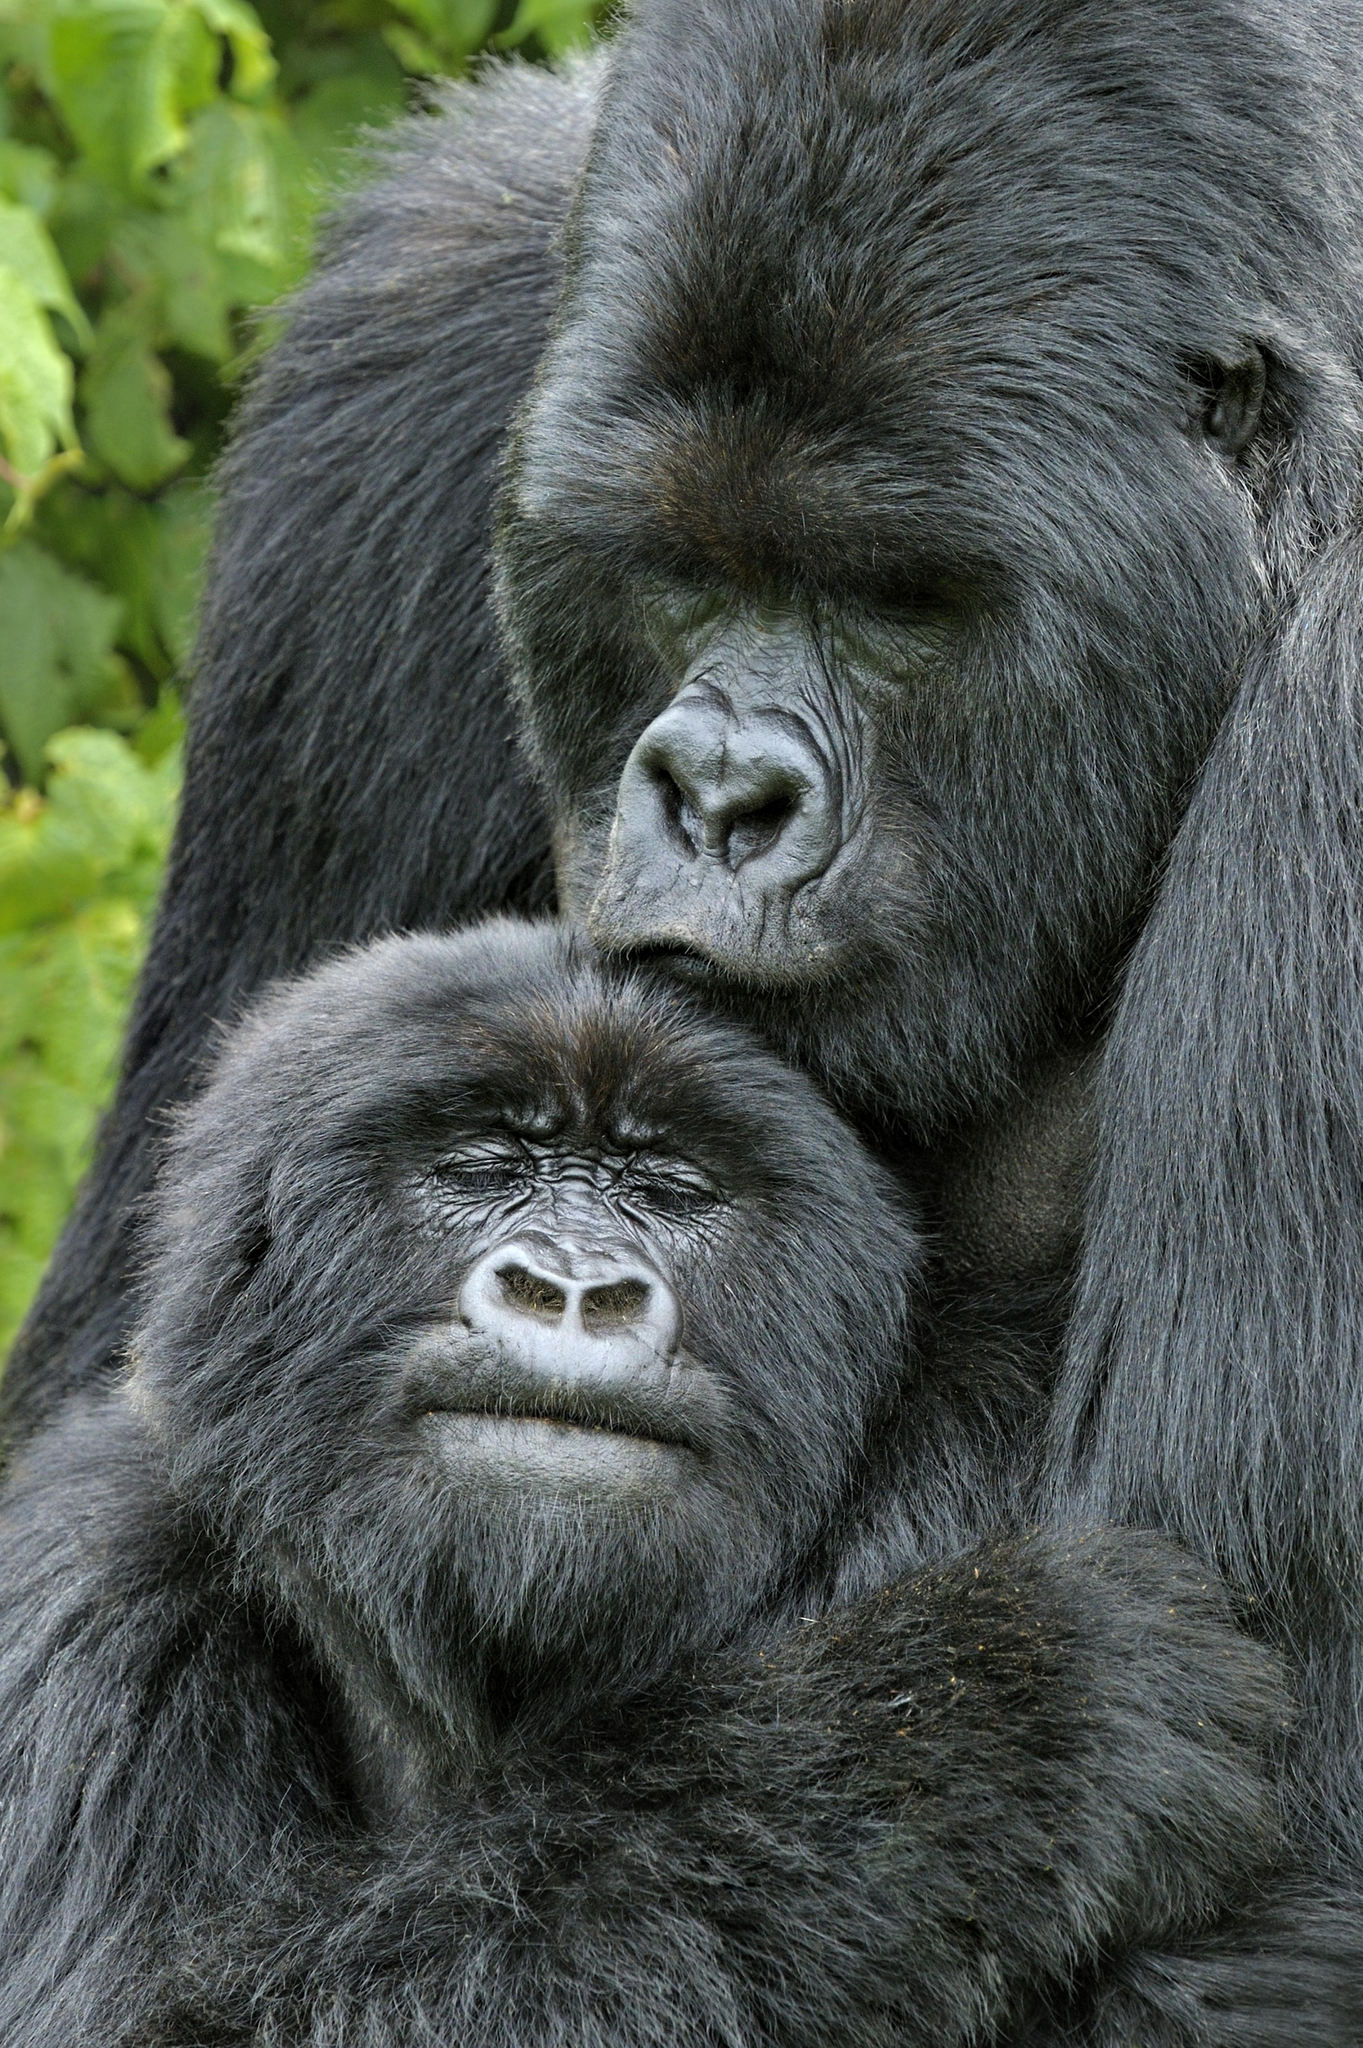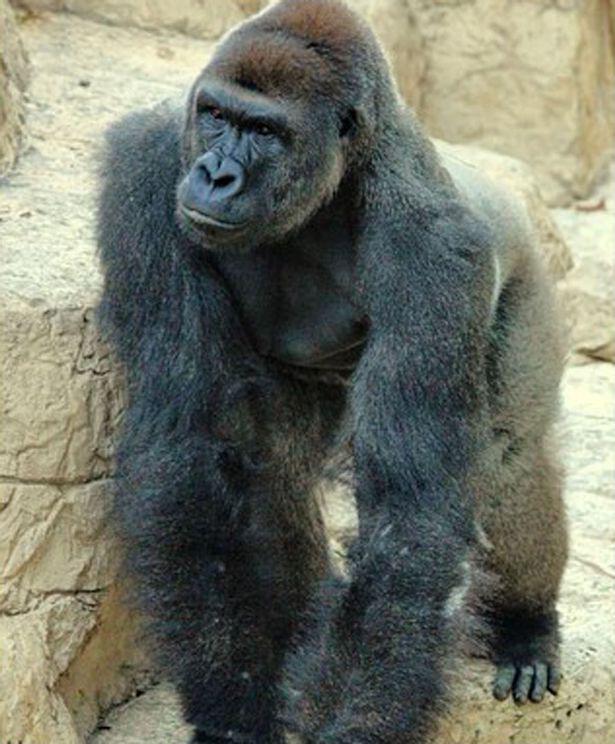The first image is the image on the left, the second image is the image on the right. Examine the images to the left and right. Is the description "An image shows a young gorilla close to an adult gorilla." accurate? Answer yes or no. Yes. 